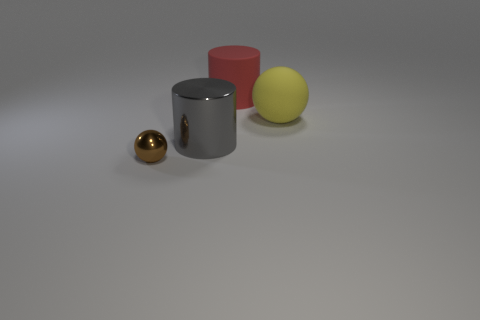Add 4 large brown cubes. How many objects exist? 8 Subtract all small purple objects. Subtract all yellow rubber things. How many objects are left? 3 Add 4 brown metal objects. How many brown metal objects are left? 5 Add 2 big cyan shiny cylinders. How many big cyan shiny cylinders exist? 2 Subtract 0 green blocks. How many objects are left? 4 